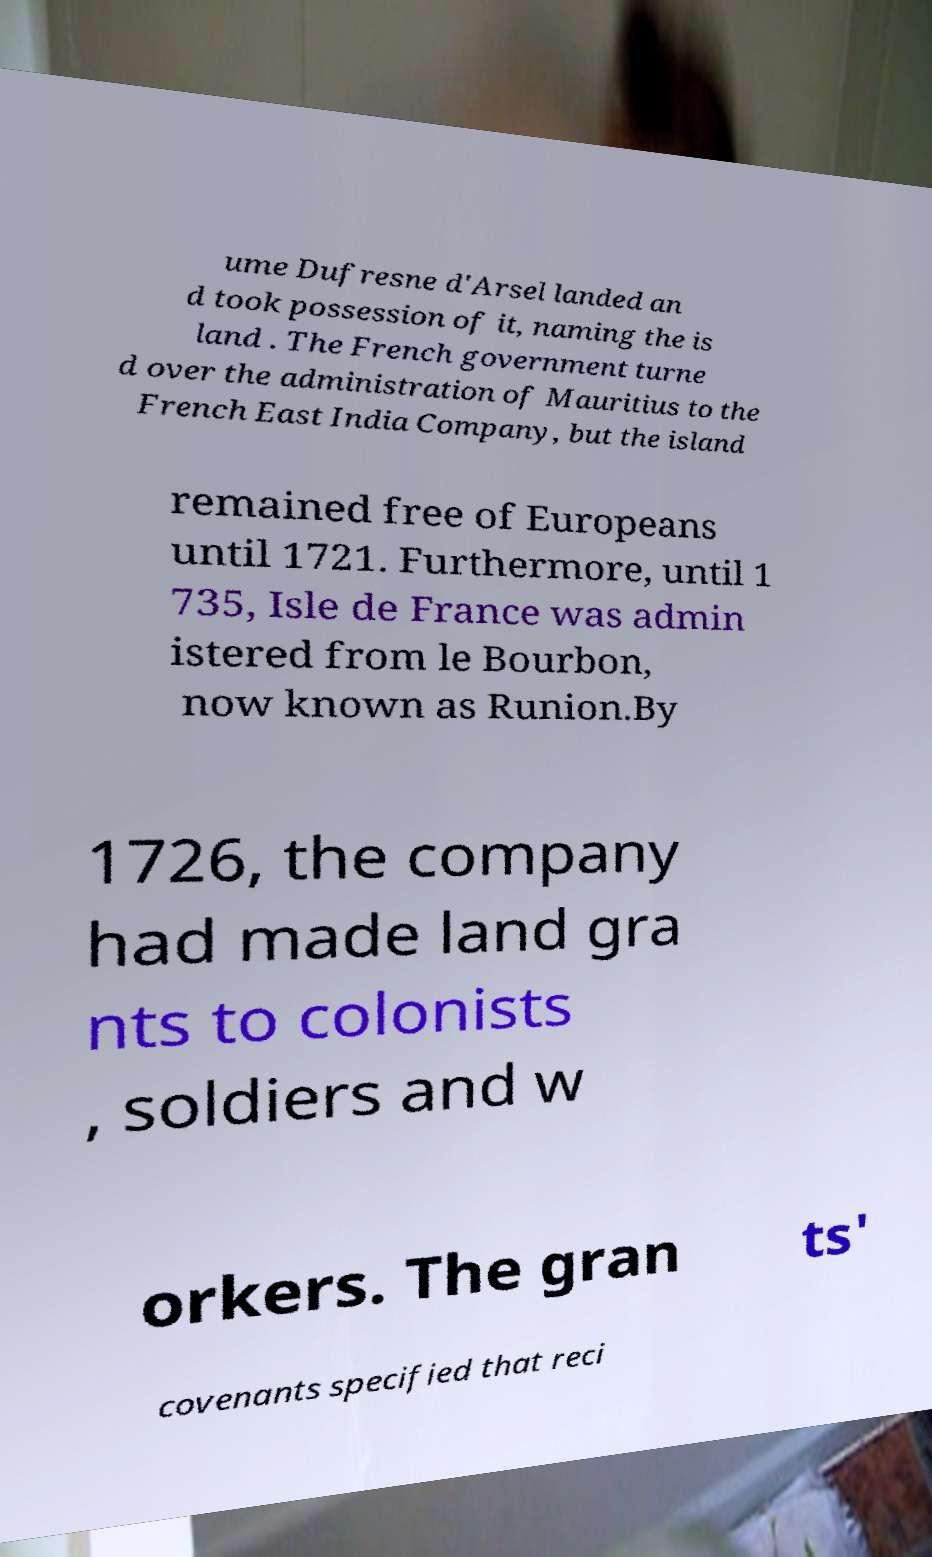I need the written content from this picture converted into text. Can you do that? ume Dufresne d'Arsel landed an d took possession of it, naming the is land . The French government turne d over the administration of Mauritius to the French East India Company, but the island remained free of Europeans until 1721. Furthermore, until 1 735, Isle de France was admin istered from le Bourbon, now known as Runion.By 1726, the company had made land gra nts to colonists , soldiers and w orkers. The gran ts' covenants specified that reci 